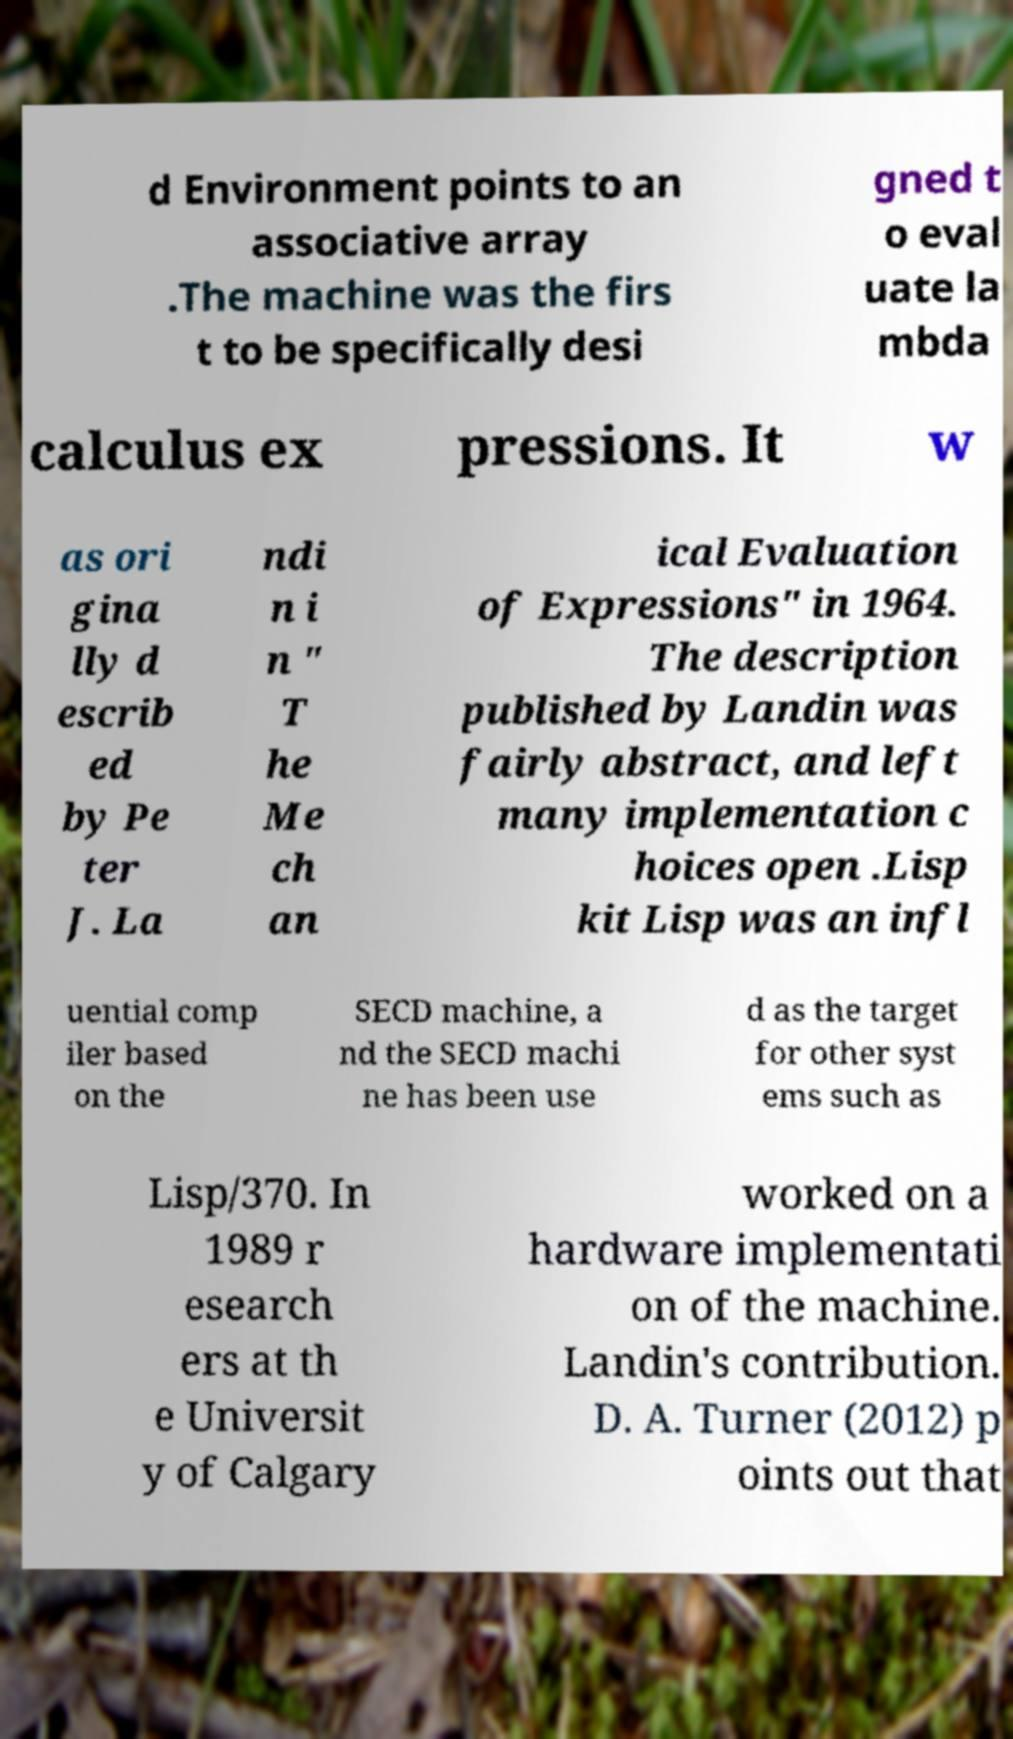Please read and relay the text visible in this image. What does it say? d Environment points to an associative array .The machine was the firs t to be specifically desi gned t o eval uate la mbda calculus ex pressions. It w as ori gina lly d escrib ed by Pe ter J. La ndi n i n " T he Me ch an ical Evaluation of Expressions" in 1964. The description published by Landin was fairly abstract, and left many implementation c hoices open .Lisp kit Lisp was an infl uential comp iler based on the SECD machine, a nd the SECD machi ne has been use d as the target for other syst ems such as Lisp/370. In 1989 r esearch ers at th e Universit y of Calgary worked on a hardware implementati on of the machine. Landin's contribution. D. A. Turner (2012) p oints out that 